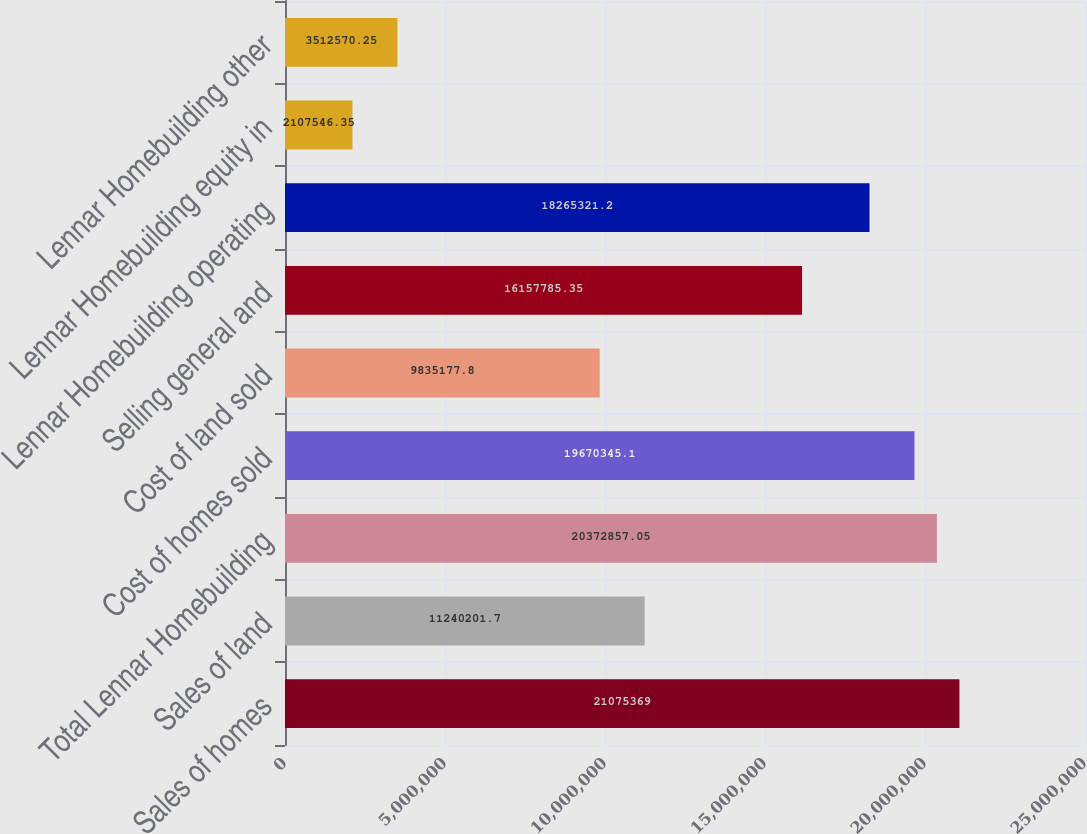<chart> <loc_0><loc_0><loc_500><loc_500><bar_chart><fcel>Sales of homes<fcel>Sales of land<fcel>Total Lennar Homebuilding<fcel>Cost of homes sold<fcel>Cost of land sold<fcel>Selling general and<fcel>Lennar Homebuilding operating<fcel>Lennar Homebuilding equity in<fcel>Lennar Homebuilding other<nl><fcel>2.10754e+07<fcel>1.12402e+07<fcel>2.03729e+07<fcel>1.96703e+07<fcel>9.83518e+06<fcel>1.61578e+07<fcel>1.82653e+07<fcel>2.10755e+06<fcel>3.51257e+06<nl></chart> 